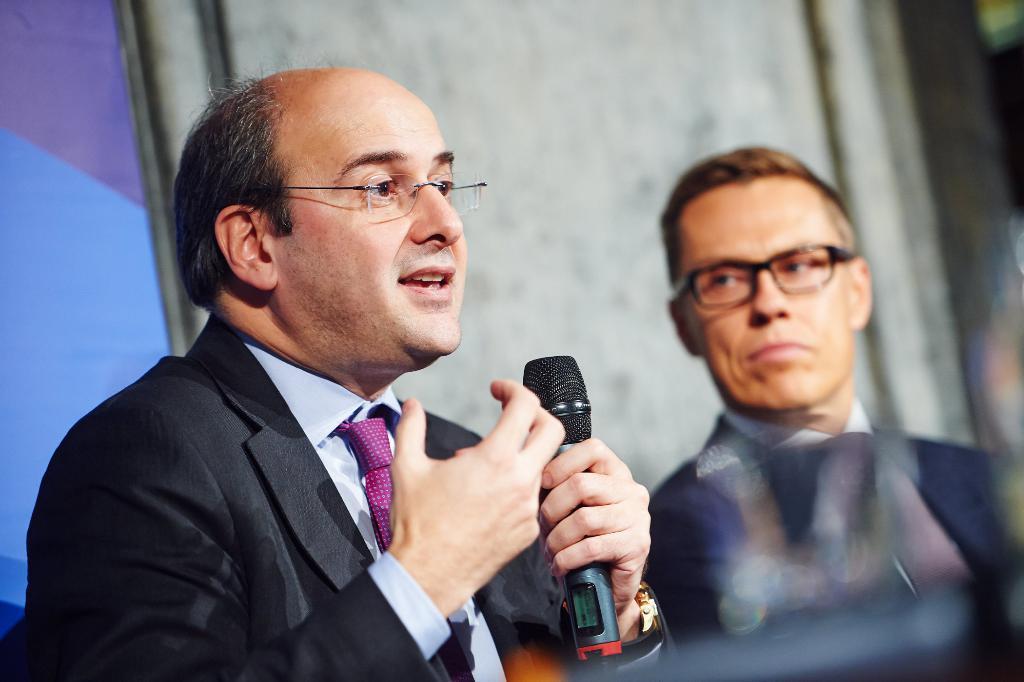In one or two sentences, can you explain what this image depicts? In this image I can see in two men and the person on the right side is holding a microphone in his hand. 